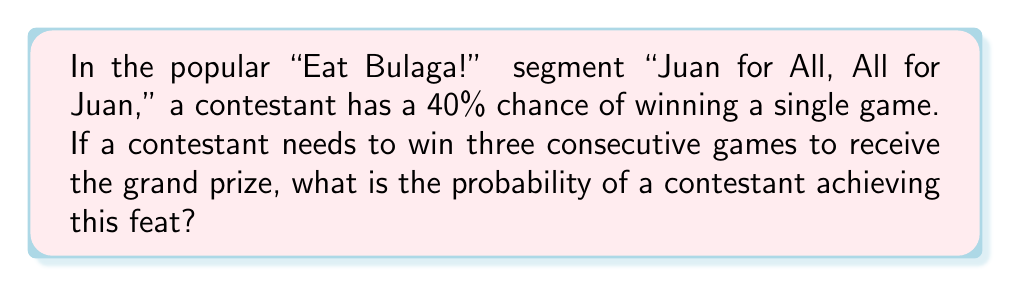Can you solve this math problem? Let's approach this step-by-step using conditional probability:

1) Let $W_i$ represent winning the $i$-th game.

2) We need to calculate $P(W_1 \cap W_2 \cap W_3)$.

3) Using the chain rule of probability:

   $P(W_1 \cap W_2 \cap W_3) = P(W_1) \cdot P(W_2|W_1) \cdot P(W_3|W_1 \cap W_2)$

4) Given:
   - The probability of winning each game is independent and always 40%.
   - $P(W_1) = P(W_2) = P(W_3) = 0.4$

5) Therefore:
   $P(W_2|W_1) = P(W_2) = 0.4$
   $P(W_3|W_1 \cap W_2) = P(W_3) = 0.4$

6) Substituting these values:

   $P(W_1 \cap W_2 \cap W_3) = 0.4 \cdot 0.4 \cdot 0.4 = 0.4^3 = 0.064$

7) Converting to a percentage:

   $0.064 \cdot 100\% = 6.4\%$
Answer: 6.4% 